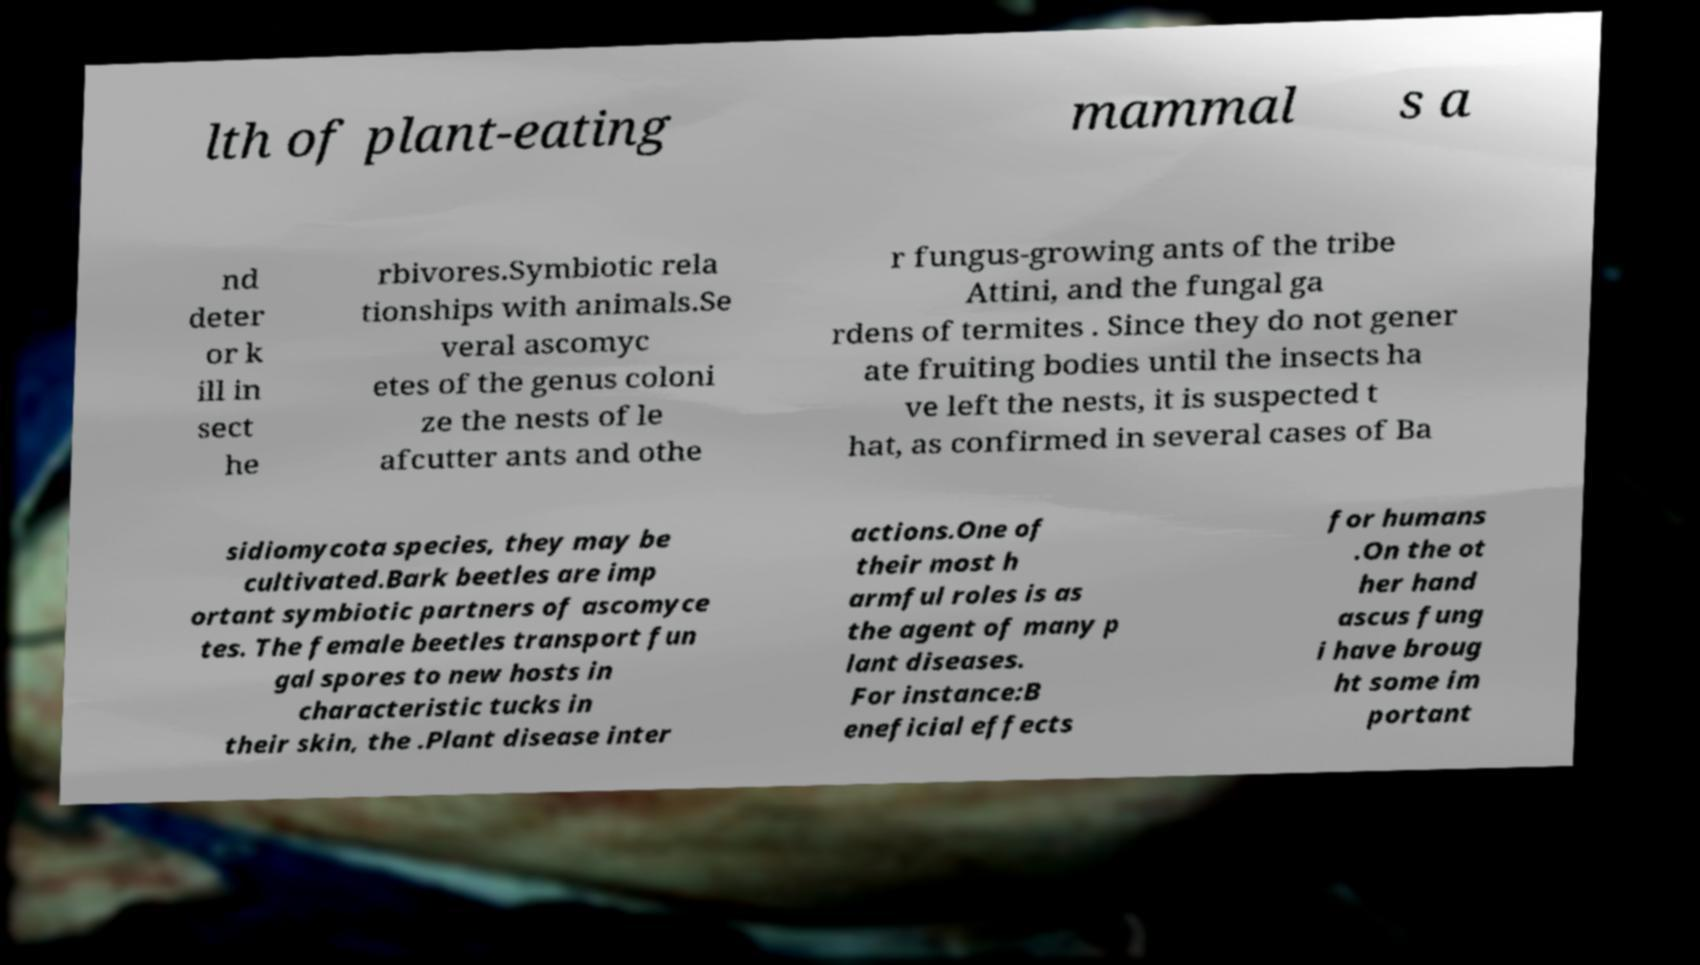I need the written content from this picture converted into text. Can you do that? lth of plant-eating mammal s a nd deter or k ill in sect he rbivores.Symbiotic rela tionships with animals.Se veral ascomyc etes of the genus coloni ze the nests of le afcutter ants and othe r fungus-growing ants of the tribe Attini, and the fungal ga rdens of termites . Since they do not gener ate fruiting bodies until the insects ha ve left the nests, it is suspected t hat, as confirmed in several cases of Ba sidiomycota species, they may be cultivated.Bark beetles are imp ortant symbiotic partners of ascomyce tes. The female beetles transport fun gal spores to new hosts in characteristic tucks in their skin, the .Plant disease inter actions.One of their most h armful roles is as the agent of many p lant diseases. For instance:B eneficial effects for humans .On the ot her hand ascus fung i have broug ht some im portant 